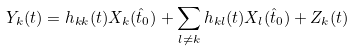<formula> <loc_0><loc_0><loc_500><loc_500>Y _ { k } ( t ) = h _ { k k } ( t ) X _ { k } ( \hat { t } _ { 0 } ) + \sum _ { l \ne k } h _ { k l } ( t ) X _ { l } ( \hat { t } _ { 0 } ) + Z _ { k } ( t )</formula> 